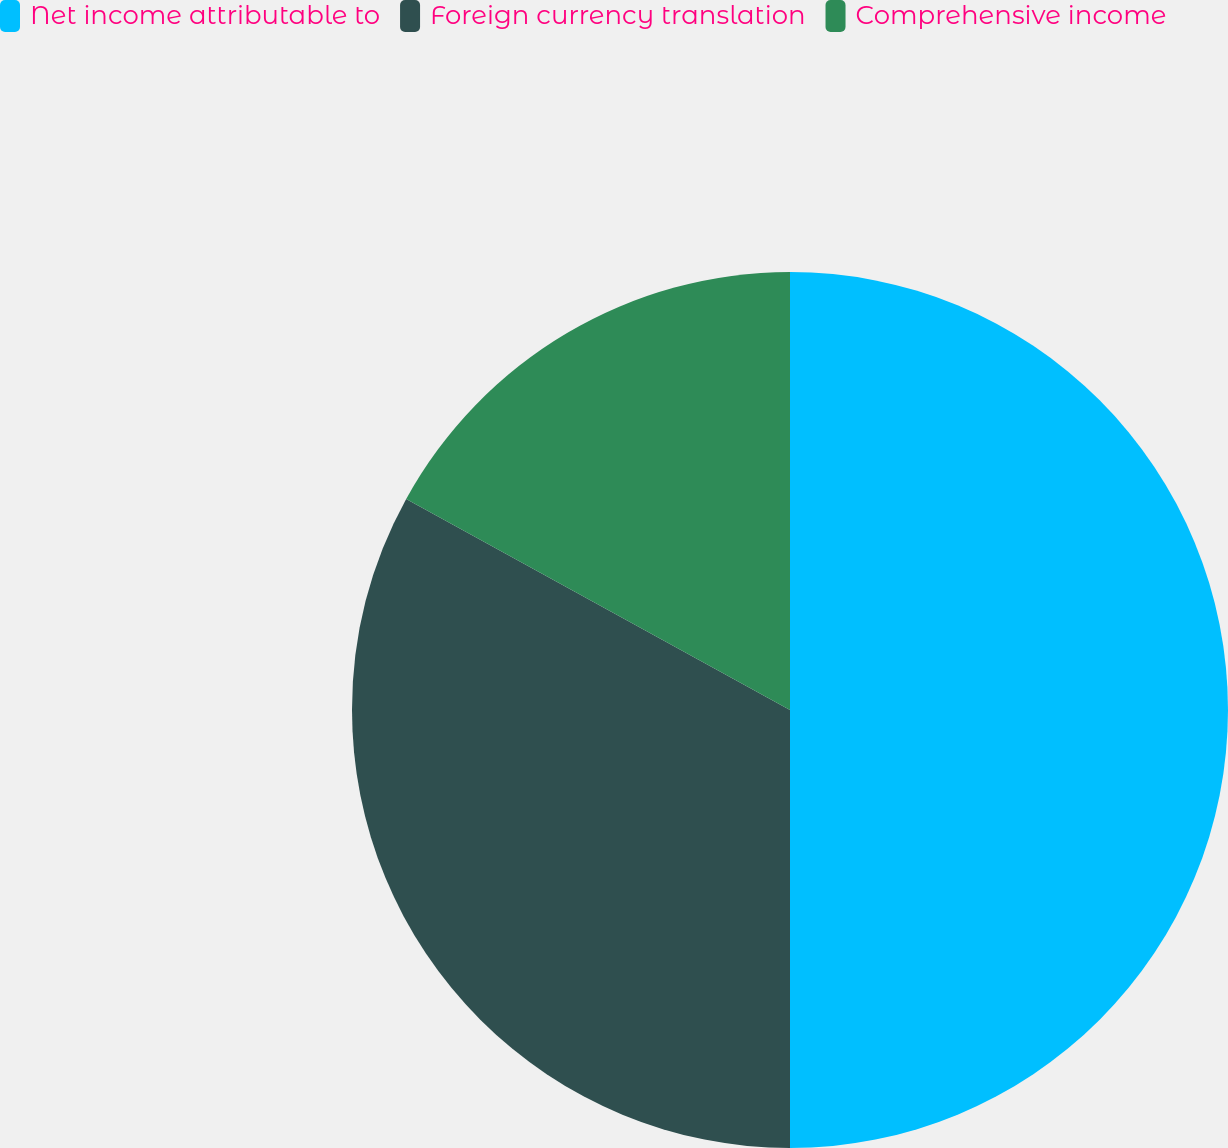Convert chart. <chart><loc_0><loc_0><loc_500><loc_500><pie_chart><fcel>Net income attributable to<fcel>Foreign currency translation<fcel>Comprehensive income<nl><fcel>50.0%<fcel>33.0%<fcel>17.0%<nl></chart> 